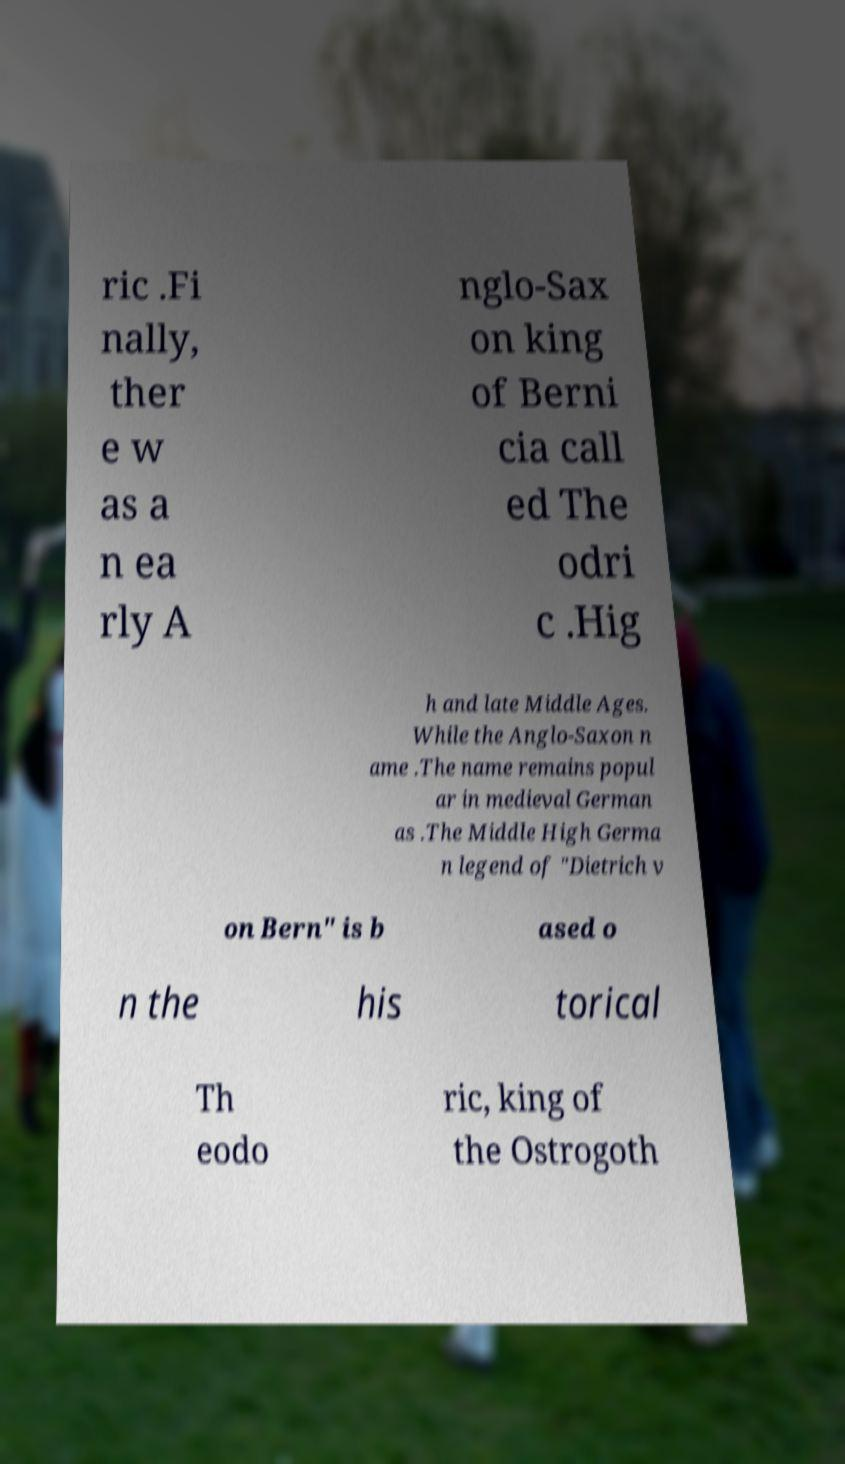What messages or text are displayed in this image? I need them in a readable, typed format. ric .Fi nally, ther e w as a n ea rly A nglo-Sax on king of Berni cia call ed The odri c .Hig h and late Middle Ages. While the Anglo-Saxon n ame .The name remains popul ar in medieval German as .The Middle High Germa n legend of "Dietrich v on Bern" is b ased o n the his torical Th eodo ric, king of the Ostrogoth 